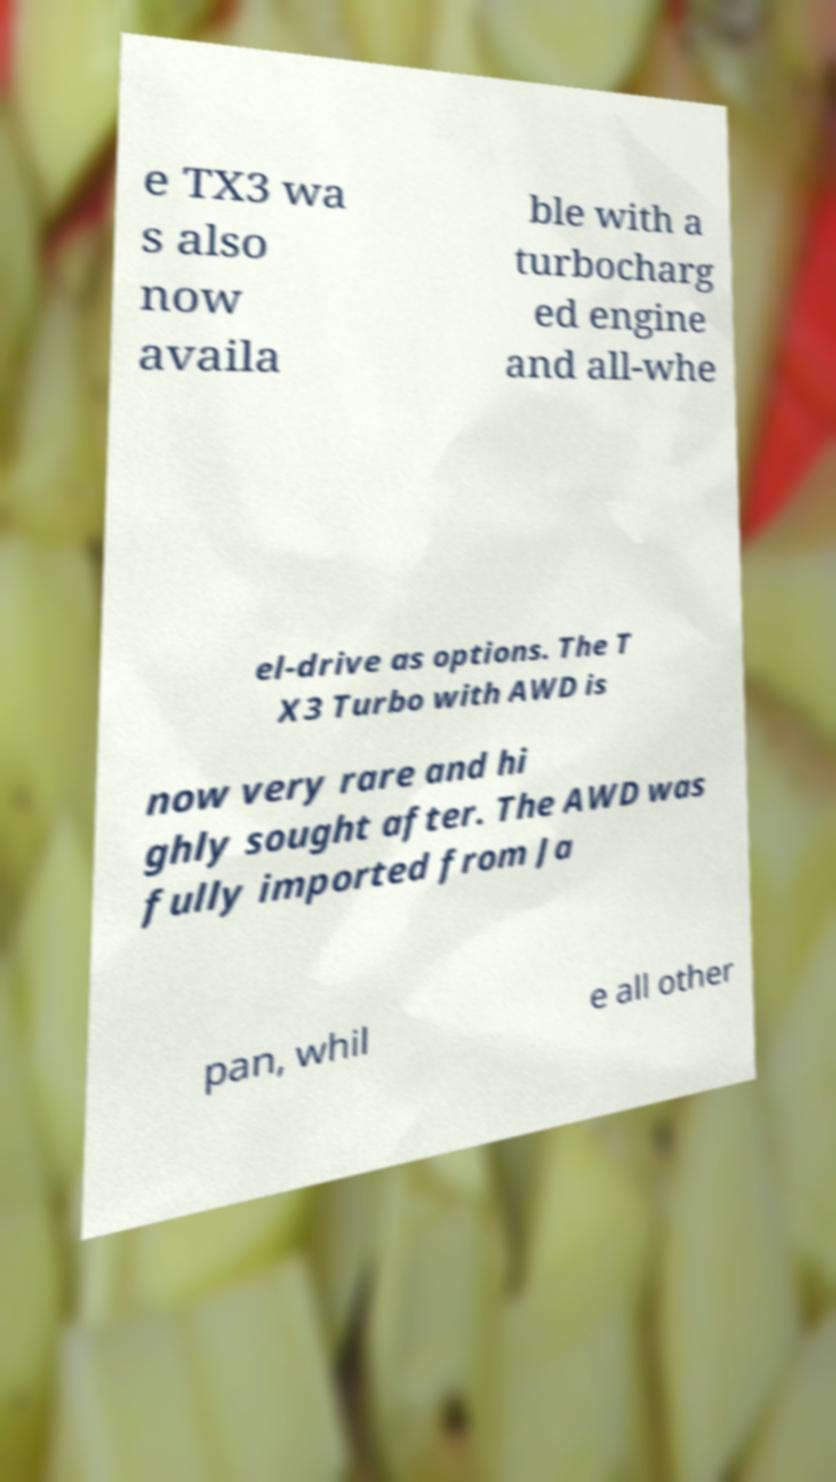I need the written content from this picture converted into text. Can you do that? e TX3 wa s also now availa ble with a turbocharg ed engine and all-whe el-drive as options. The T X3 Turbo with AWD is now very rare and hi ghly sought after. The AWD was fully imported from Ja pan, whil e all other 